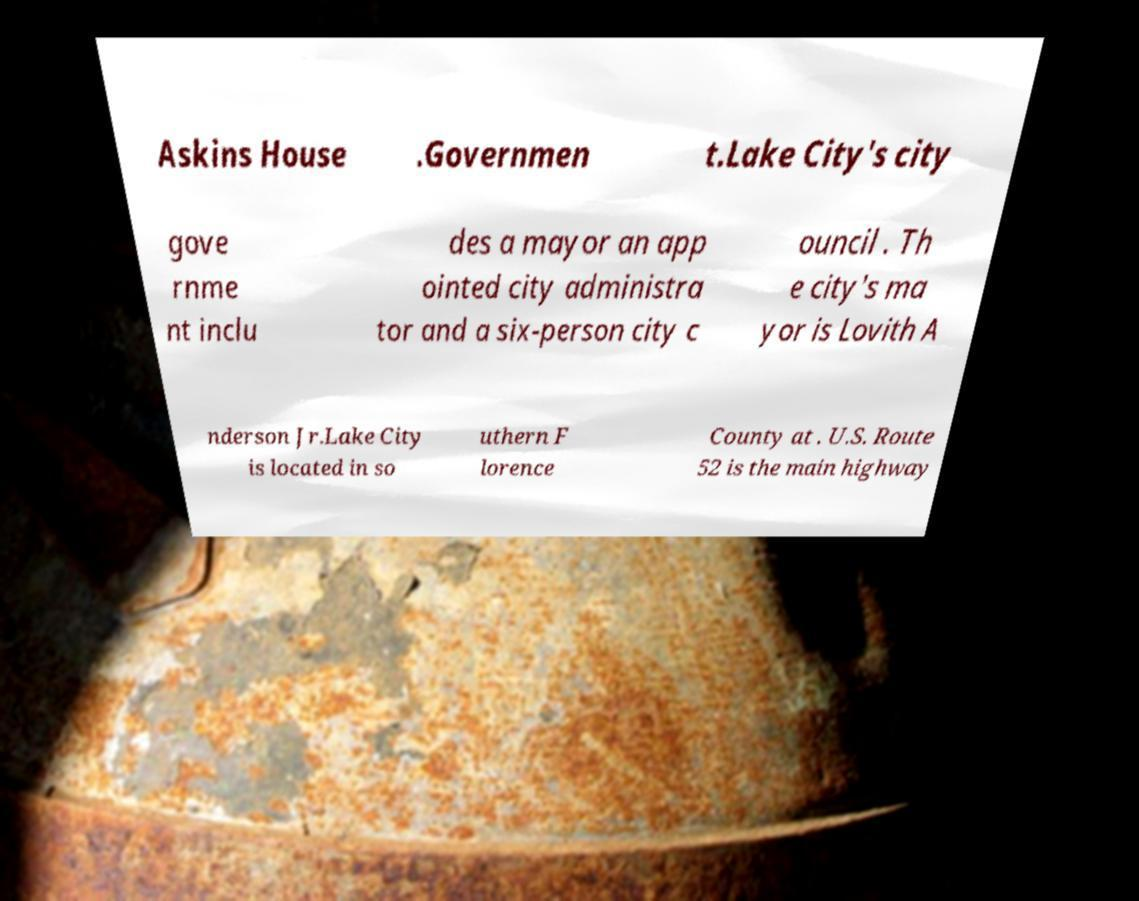Please identify and transcribe the text found in this image. Askins House .Governmen t.Lake City's city gove rnme nt inclu des a mayor an app ointed city administra tor and a six-person city c ouncil . Th e city's ma yor is Lovith A nderson Jr.Lake City is located in so uthern F lorence County at . U.S. Route 52 is the main highway 